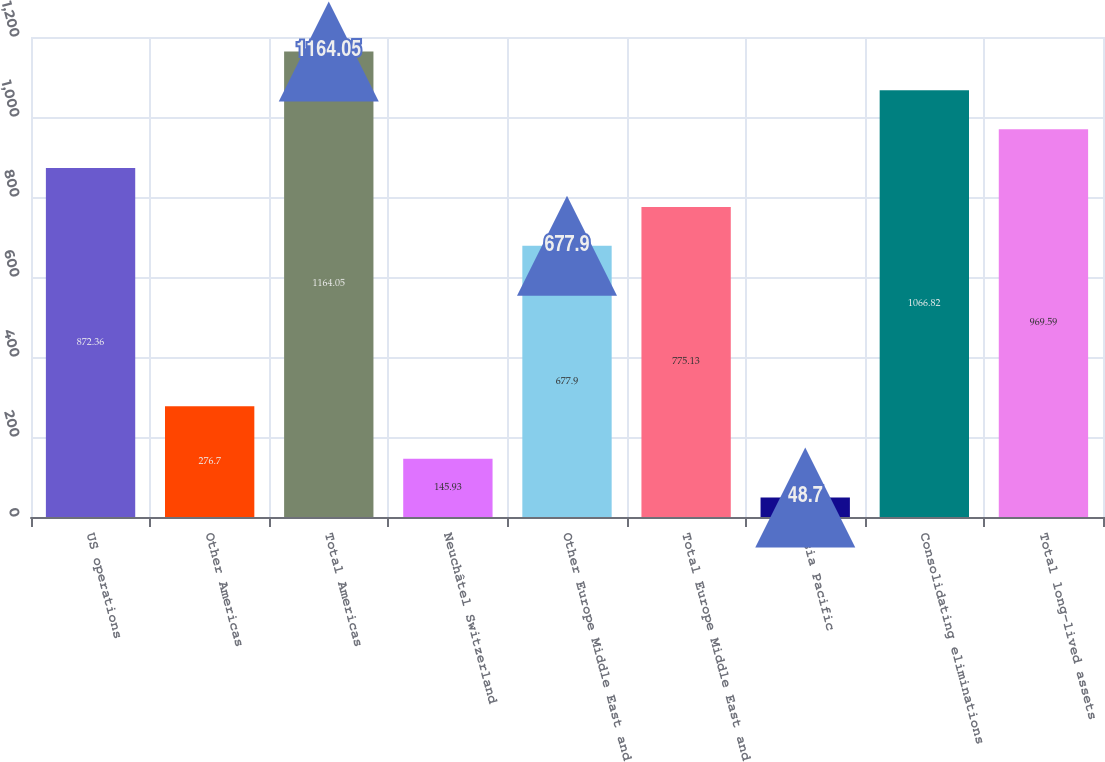Convert chart to OTSL. <chart><loc_0><loc_0><loc_500><loc_500><bar_chart><fcel>US operations<fcel>Other Americas<fcel>Total Americas<fcel>Neuchâtel Switzerland<fcel>Other Europe Middle East and<fcel>Total Europe Middle East and<fcel>Asia Pacific<fcel>Consolidating eliminations<fcel>Total long-lived assets<nl><fcel>872.36<fcel>276.7<fcel>1164.05<fcel>145.93<fcel>677.9<fcel>775.13<fcel>48.7<fcel>1066.82<fcel>969.59<nl></chart> 